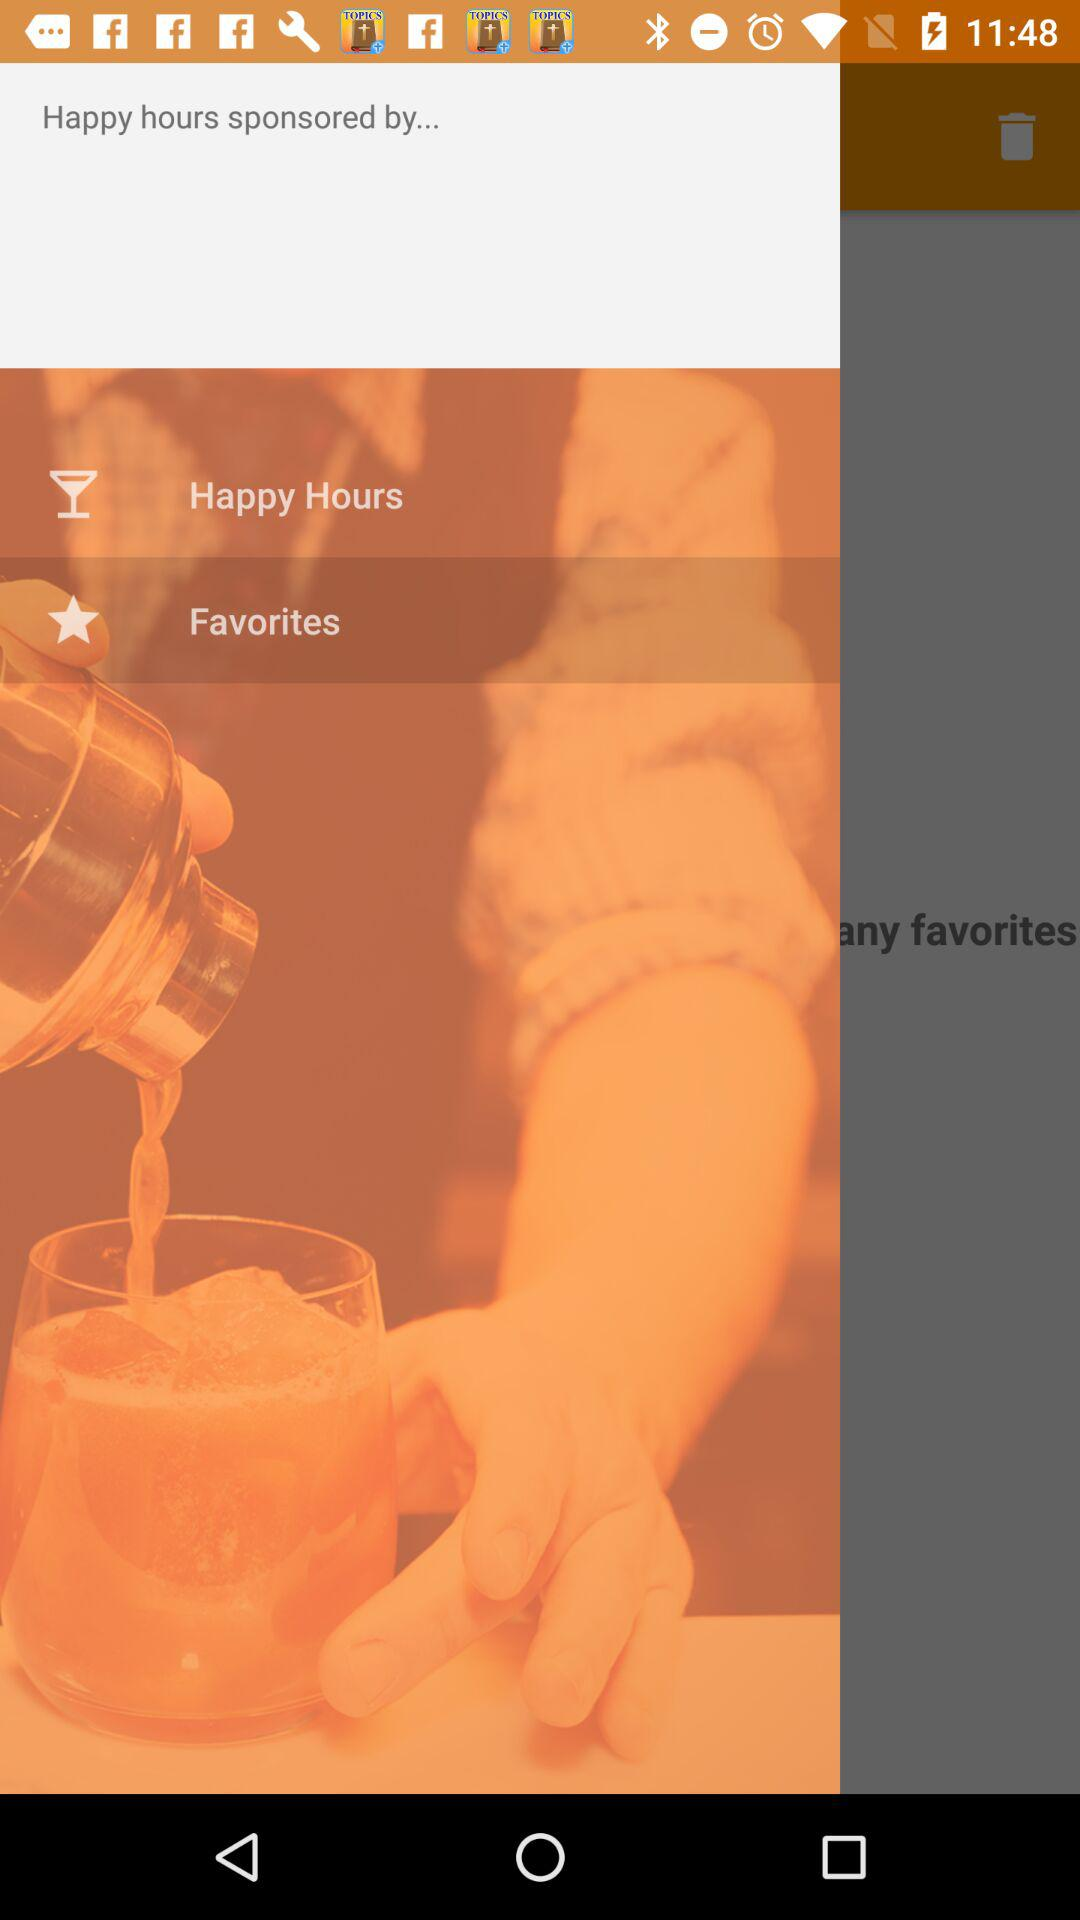Which option is selected? The selected option is Favorites. 